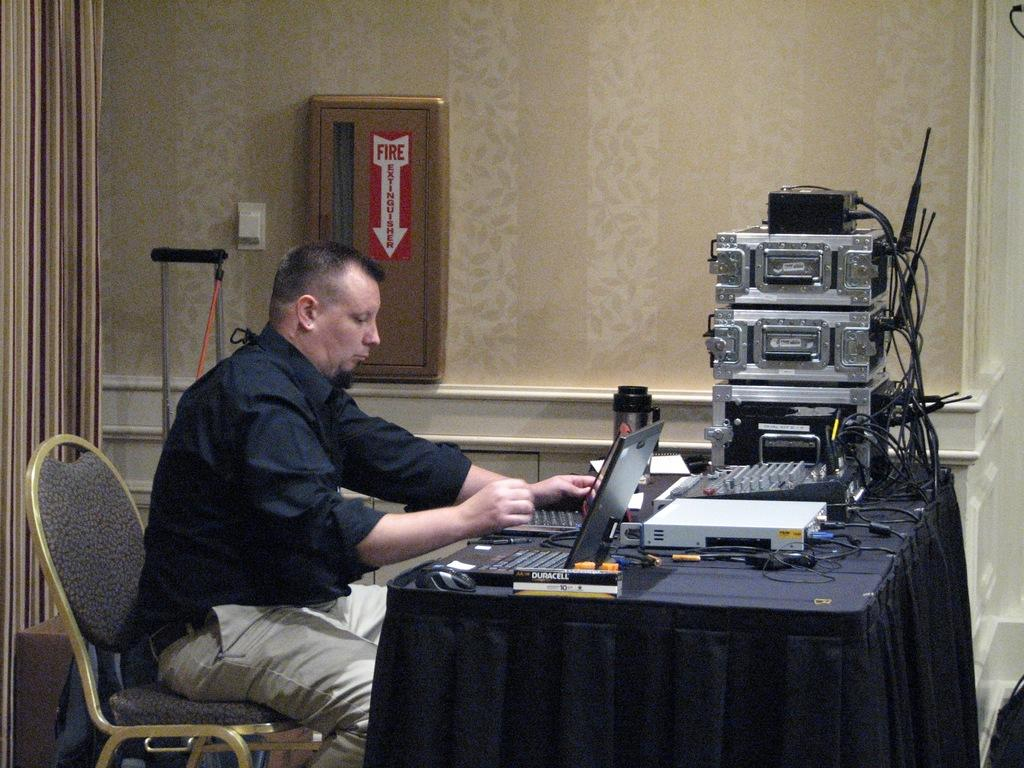What is the person in the image doing? The person is sitting on a chair in the image. What is in front of the chair? There is a table in front of the chair. What can be seen on the table? There are laptops, instruments, and books on the table. What year is the playground mentioned in the image? There is no mention of a playground in the image. 